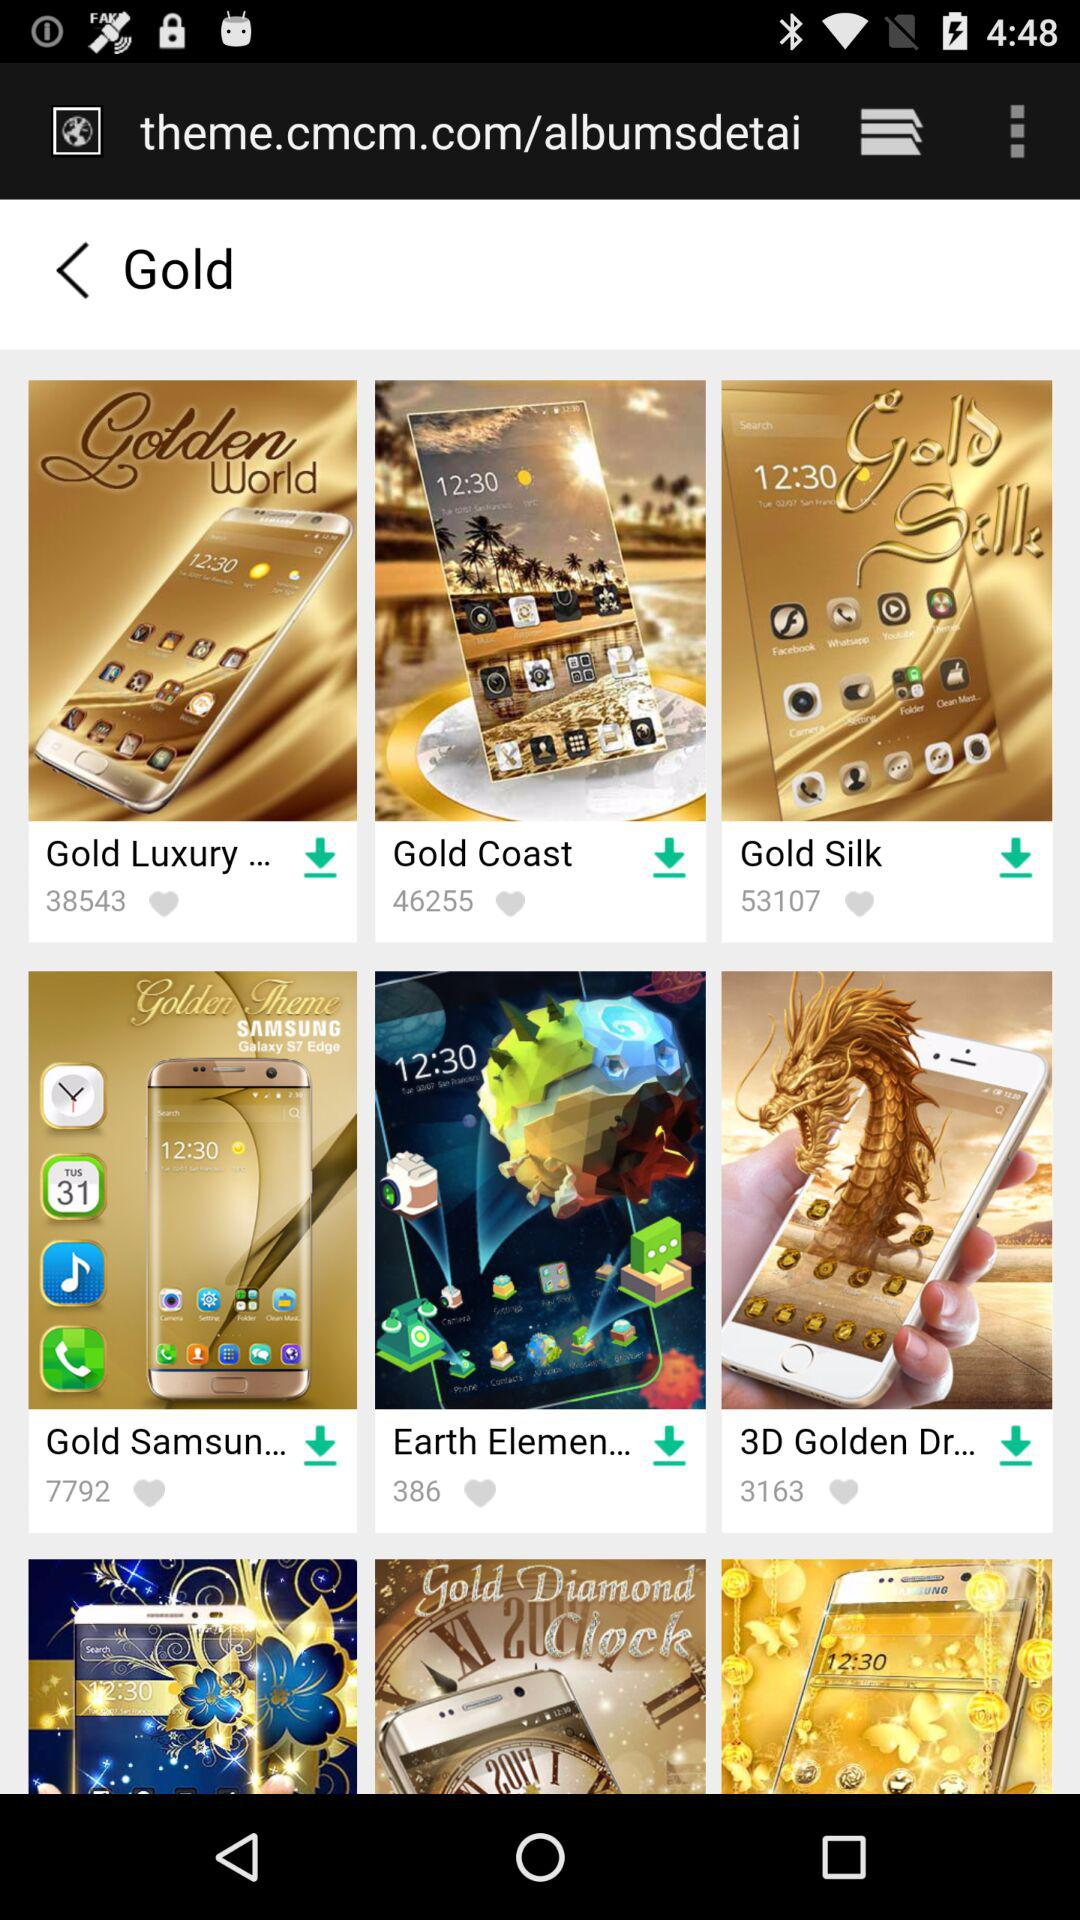Which theme has 386 likes?
Answer the question using a single word or phrase. The theme is "Earth Elemen..." 